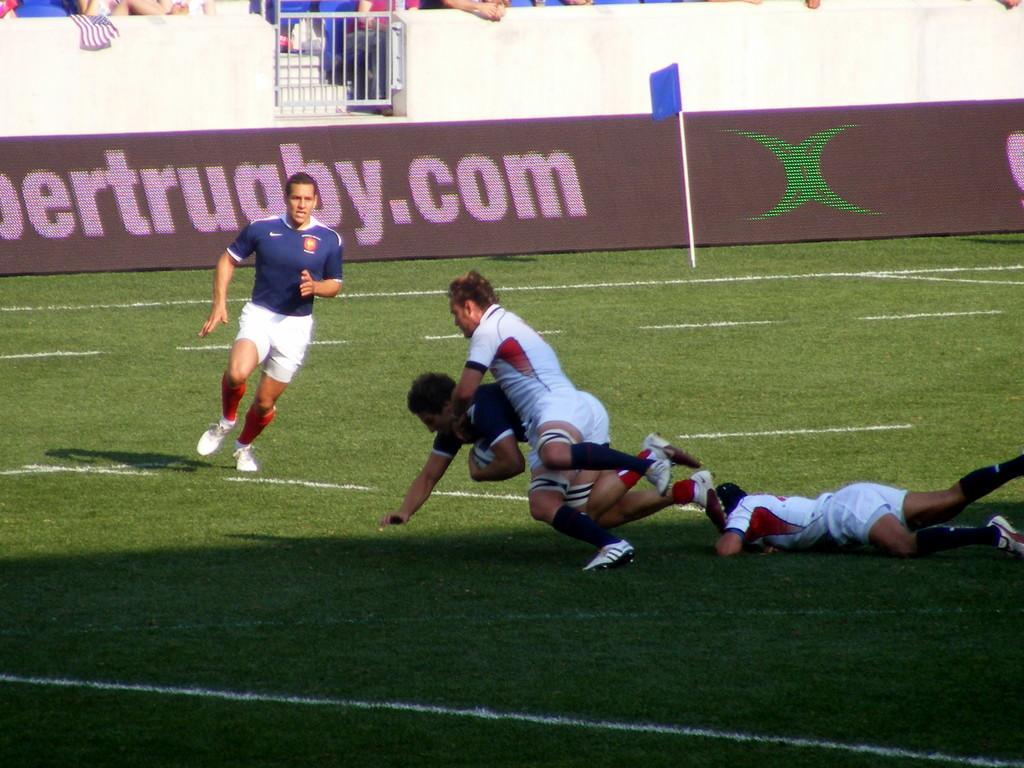Please provide a concise description of this image. In this picture we can see four men running and trying to take ball from this person and in background we can see gate, wall, flag, pole, some persons. 